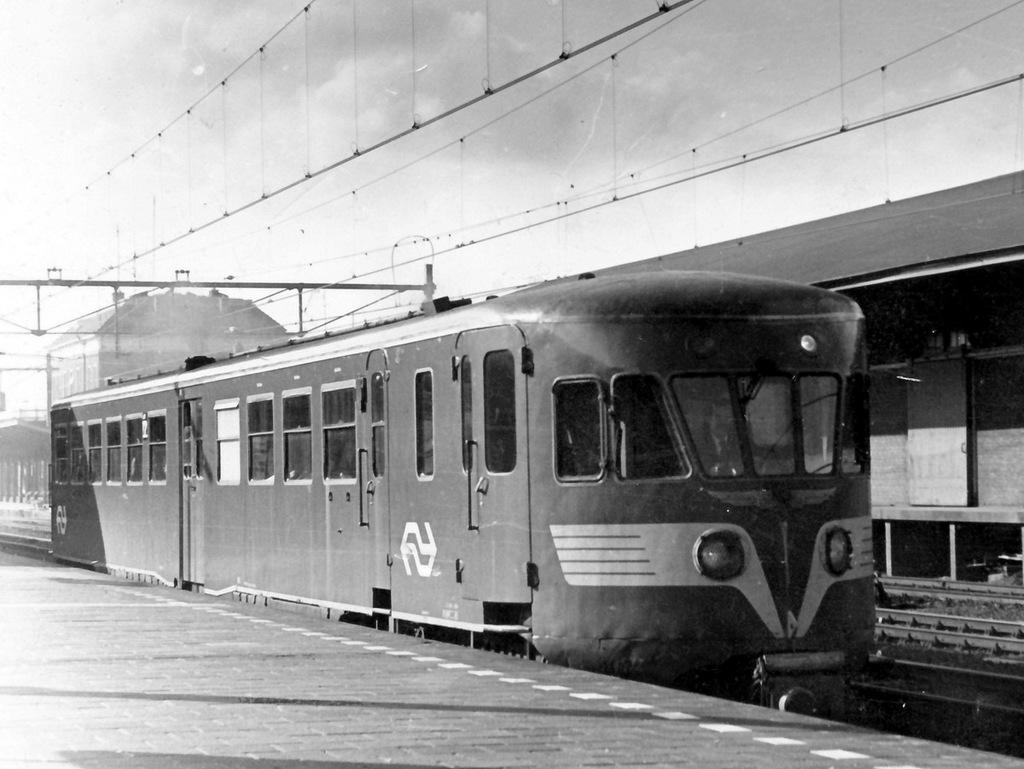What is the color scheme of the image? The image is black and white. What is the main subject of the image? There is a train in the image. Where is the train located in the image? The train is on a railway track. What can be seen at the top of the image? There are wires at the top of the image. What is visible in the background of the image? There appears to be a building in the background of the image. Is there a hospital in the image where the train is about to make a stop? There is no hospital visible in the image, nor is there any indication that the train is about to make a stop. 